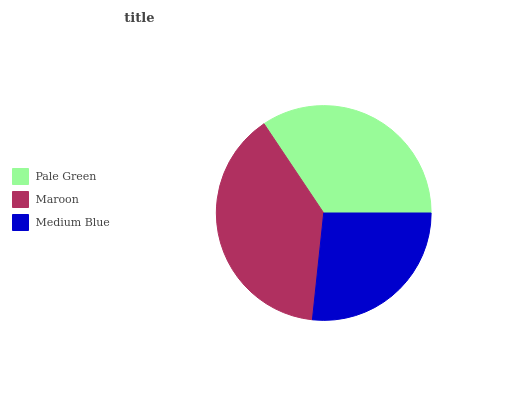Is Medium Blue the minimum?
Answer yes or no. Yes. Is Maroon the maximum?
Answer yes or no. Yes. Is Maroon the minimum?
Answer yes or no. No. Is Medium Blue the maximum?
Answer yes or no. No. Is Maroon greater than Medium Blue?
Answer yes or no. Yes. Is Medium Blue less than Maroon?
Answer yes or no. Yes. Is Medium Blue greater than Maroon?
Answer yes or no. No. Is Maroon less than Medium Blue?
Answer yes or no. No. Is Pale Green the high median?
Answer yes or no. Yes. Is Pale Green the low median?
Answer yes or no. Yes. Is Maroon the high median?
Answer yes or no. No. Is Maroon the low median?
Answer yes or no. No. 